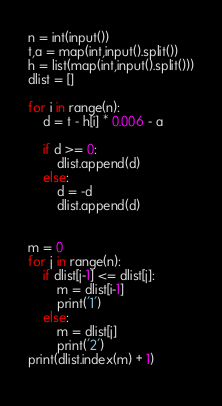Convert code to text. <code><loc_0><loc_0><loc_500><loc_500><_Python_>n = int(input())
t,a = map(int,input().split())
h = list(map(int,input().split()))
dlist = []

for i in range(n):
    d = t - h[i] * 0.006 - a
    
    if d >= 0:
        dlist.append(d)
    else:
        d = -d
        dlist.append(d)
        
        
m = 0
for j in range(n):
    if dlist[j-1] <= dlist[j]:
        m = dlist[i-1]
        print('1')
    else:
        m = dlist[j]
        print('2')
print(dlist.index(m) + 1)
    </code> 